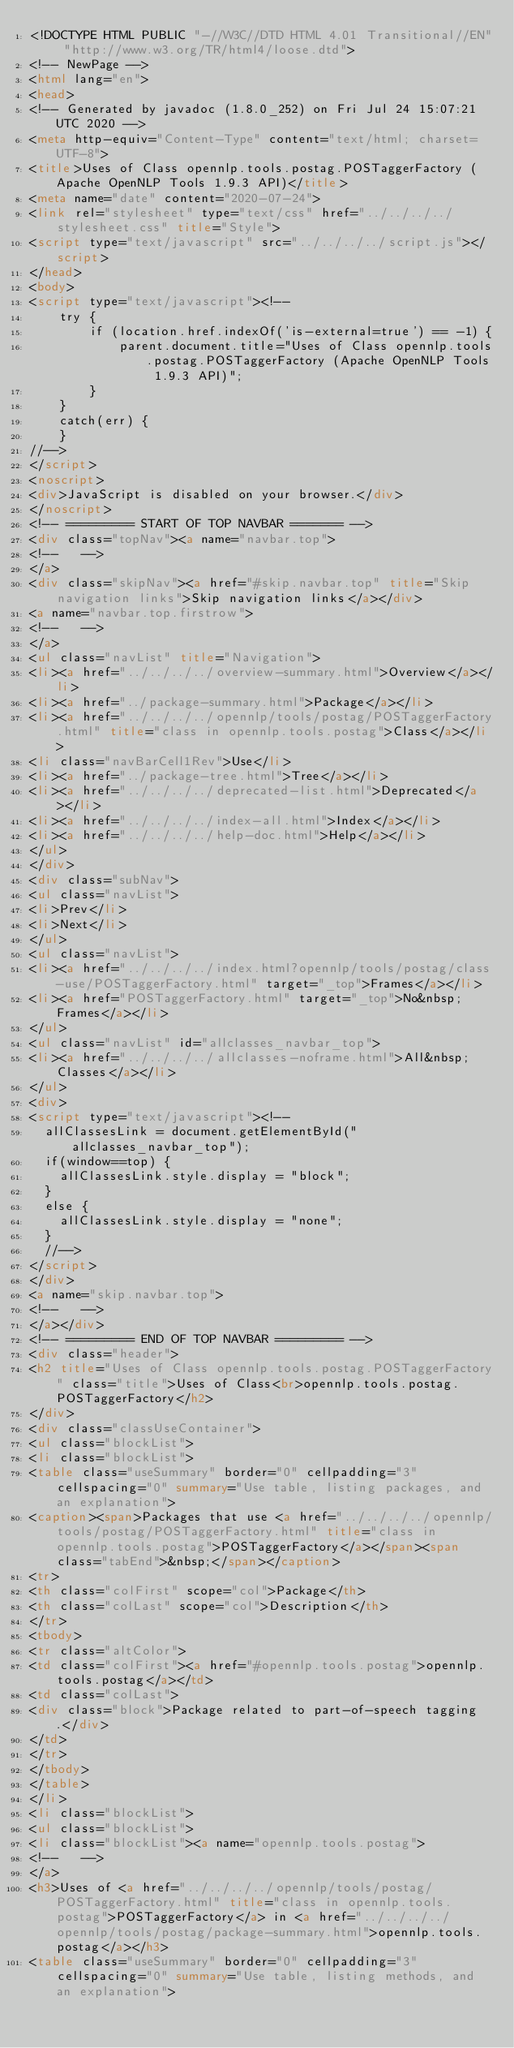Convert code to text. <code><loc_0><loc_0><loc_500><loc_500><_HTML_><!DOCTYPE HTML PUBLIC "-//W3C//DTD HTML 4.01 Transitional//EN" "http://www.w3.org/TR/html4/loose.dtd">
<!-- NewPage -->
<html lang="en">
<head>
<!-- Generated by javadoc (1.8.0_252) on Fri Jul 24 15:07:21 UTC 2020 -->
<meta http-equiv="Content-Type" content="text/html; charset=UTF-8">
<title>Uses of Class opennlp.tools.postag.POSTaggerFactory (Apache OpenNLP Tools 1.9.3 API)</title>
<meta name="date" content="2020-07-24">
<link rel="stylesheet" type="text/css" href="../../../../stylesheet.css" title="Style">
<script type="text/javascript" src="../../../../script.js"></script>
</head>
<body>
<script type="text/javascript"><!--
    try {
        if (location.href.indexOf('is-external=true') == -1) {
            parent.document.title="Uses of Class opennlp.tools.postag.POSTaggerFactory (Apache OpenNLP Tools 1.9.3 API)";
        }
    }
    catch(err) {
    }
//-->
</script>
<noscript>
<div>JavaScript is disabled on your browser.</div>
</noscript>
<!-- ========= START OF TOP NAVBAR ======= -->
<div class="topNav"><a name="navbar.top">
<!--   -->
</a>
<div class="skipNav"><a href="#skip.navbar.top" title="Skip navigation links">Skip navigation links</a></div>
<a name="navbar.top.firstrow">
<!--   -->
</a>
<ul class="navList" title="Navigation">
<li><a href="../../../../overview-summary.html">Overview</a></li>
<li><a href="../package-summary.html">Package</a></li>
<li><a href="../../../../opennlp/tools/postag/POSTaggerFactory.html" title="class in opennlp.tools.postag">Class</a></li>
<li class="navBarCell1Rev">Use</li>
<li><a href="../package-tree.html">Tree</a></li>
<li><a href="../../../../deprecated-list.html">Deprecated</a></li>
<li><a href="../../../../index-all.html">Index</a></li>
<li><a href="../../../../help-doc.html">Help</a></li>
</ul>
</div>
<div class="subNav">
<ul class="navList">
<li>Prev</li>
<li>Next</li>
</ul>
<ul class="navList">
<li><a href="../../../../index.html?opennlp/tools/postag/class-use/POSTaggerFactory.html" target="_top">Frames</a></li>
<li><a href="POSTaggerFactory.html" target="_top">No&nbsp;Frames</a></li>
</ul>
<ul class="navList" id="allclasses_navbar_top">
<li><a href="../../../../allclasses-noframe.html">All&nbsp;Classes</a></li>
</ul>
<div>
<script type="text/javascript"><!--
  allClassesLink = document.getElementById("allclasses_navbar_top");
  if(window==top) {
    allClassesLink.style.display = "block";
  }
  else {
    allClassesLink.style.display = "none";
  }
  //-->
</script>
</div>
<a name="skip.navbar.top">
<!--   -->
</a></div>
<!-- ========= END OF TOP NAVBAR ========= -->
<div class="header">
<h2 title="Uses of Class opennlp.tools.postag.POSTaggerFactory" class="title">Uses of Class<br>opennlp.tools.postag.POSTaggerFactory</h2>
</div>
<div class="classUseContainer">
<ul class="blockList">
<li class="blockList">
<table class="useSummary" border="0" cellpadding="3" cellspacing="0" summary="Use table, listing packages, and an explanation">
<caption><span>Packages that use <a href="../../../../opennlp/tools/postag/POSTaggerFactory.html" title="class in opennlp.tools.postag">POSTaggerFactory</a></span><span class="tabEnd">&nbsp;</span></caption>
<tr>
<th class="colFirst" scope="col">Package</th>
<th class="colLast" scope="col">Description</th>
</tr>
<tbody>
<tr class="altColor">
<td class="colFirst"><a href="#opennlp.tools.postag">opennlp.tools.postag</a></td>
<td class="colLast">
<div class="block">Package related to part-of-speech tagging.</div>
</td>
</tr>
</tbody>
</table>
</li>
<li class="blockList">
<ul class="blockList">
<li class="blockList"><a name="opennlp.tools.postag">
<!--   -->
</a>
<h3>Uses of <a href="../../../../opennlp/tools/postag/POSTaggerFactory.html" title="class in opennlp.tools.postag">POSTaggerFactory</a> in <a href="../../../../opennlp/tools/postag/package-summary.html">opennlp.tools.postag</a></h3>
<table class="useSummary" border="0" cellpadding="3" cellspacing="0" summary="Use table, listing methods, and an explanation"></code> 